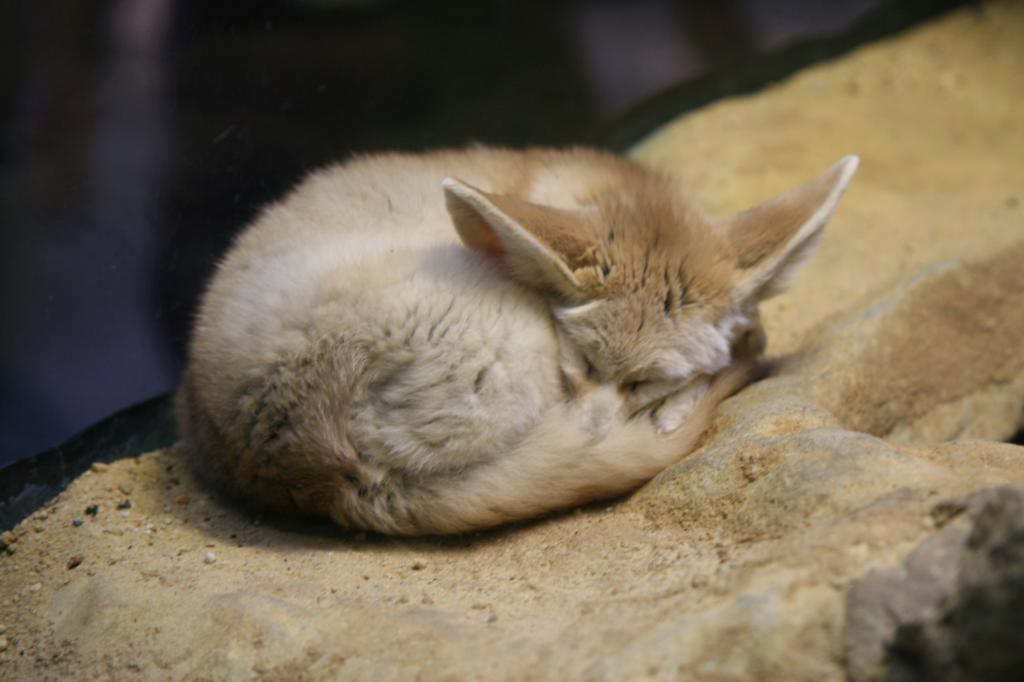What type of animal can be seen in the image? There is an animal in the image that resembles a fox. What object is located at the bottom of the image? There is a rock at the bottom of the image. What is the color of the background in the image? The background of the image is black in color. What type of star can be seen in the image? There is no star present in the image. Where is the vacation destination depicted in the image? The image does not depict a vacation destination; it features an animal that resembles a fox and a rock. 